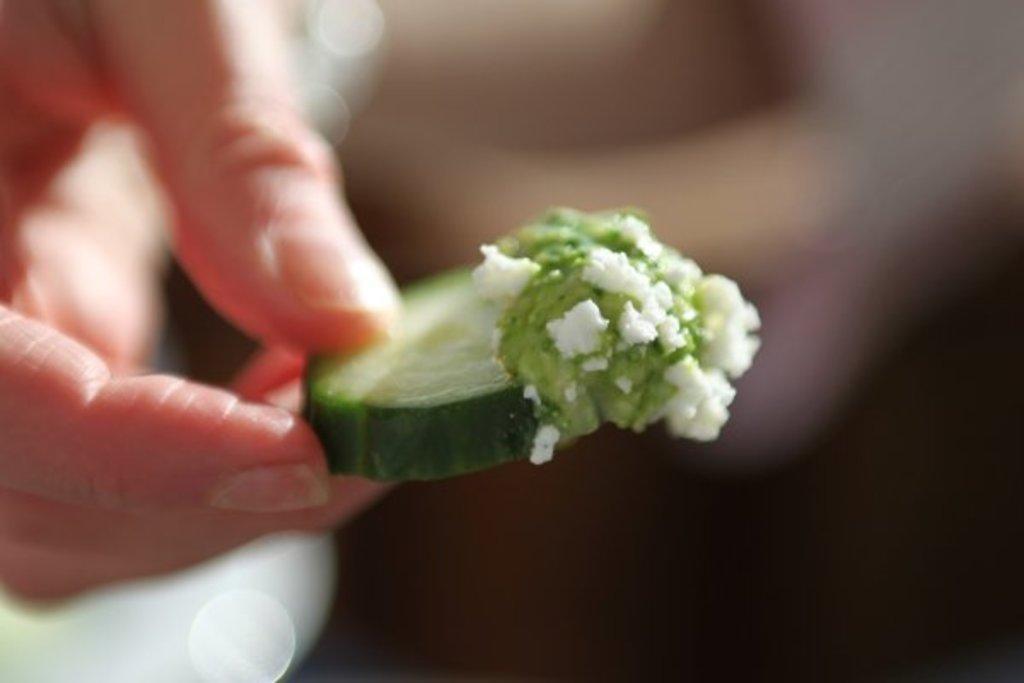In one or two sentences, can you explain what this image depicts? In this image we can see a hand of a person holding a food item and the background of the image is blur. 